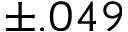Convert formula to latex. <formula><loc_0><loc_0><loc_500><loc_500>\pm . 0 4 9</formula> 